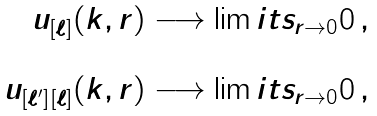Convert formula to latex. <formula><loc_0><loc_0><loc_500><loc_500>\begin{array} { r c } u _ { [ \ell ] } ( k , r ) \longrightarrow \lim i t s _ { r \to 0 } 0 \, , & \\ & \\ u _ { [ \ell ^ { \prime } ] [ \ell ] } ( k , r ) \longrightarrow \lim i t s _ { r \to 0 } 0 \, , & \end{array}</formula> 